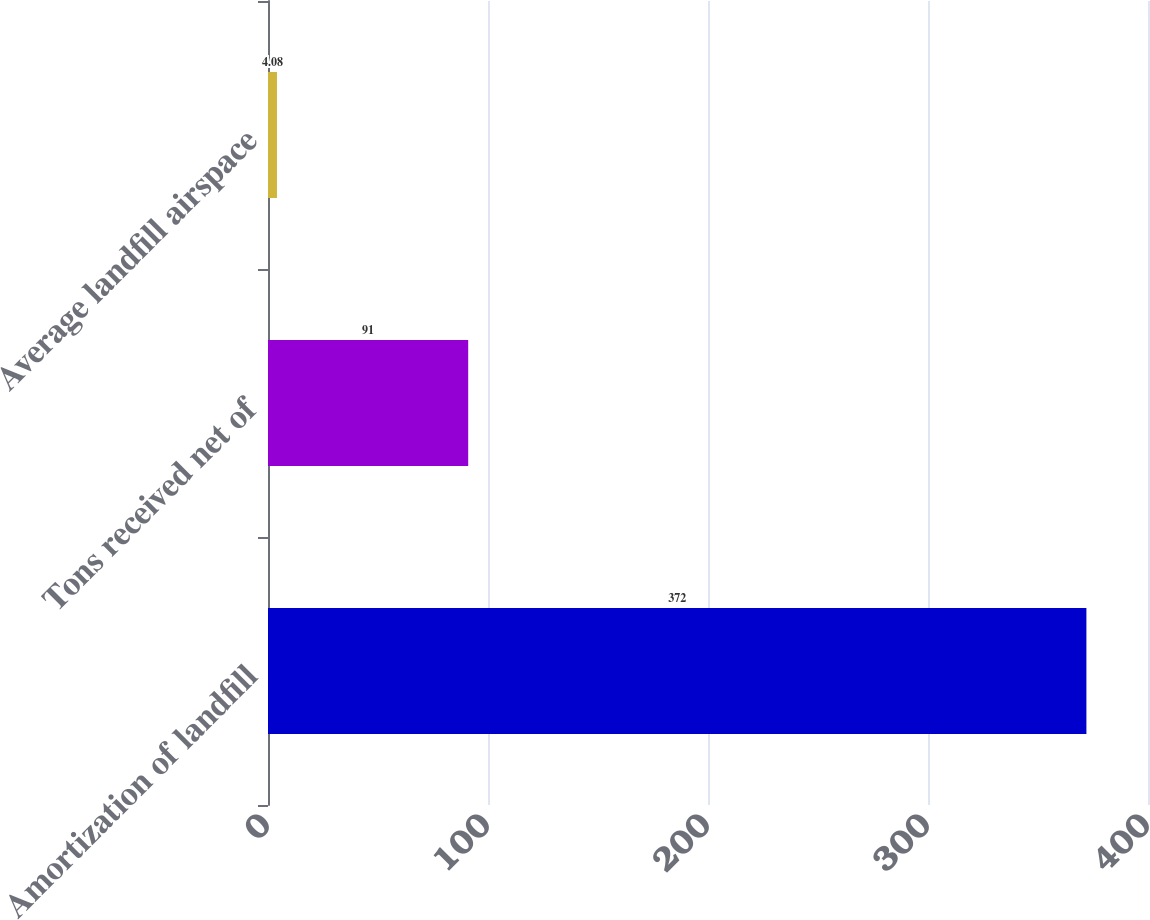Convert chart to OTSL. <chart><loc_0><loc_0><loc_500><loc_500><bar_chart><fcel>Amortization of landfill<fcel>Tons received net of<fcel>Average landfill airspace<nl><fcel>372<fcel>91<fcel>4.08<nl></chart> 